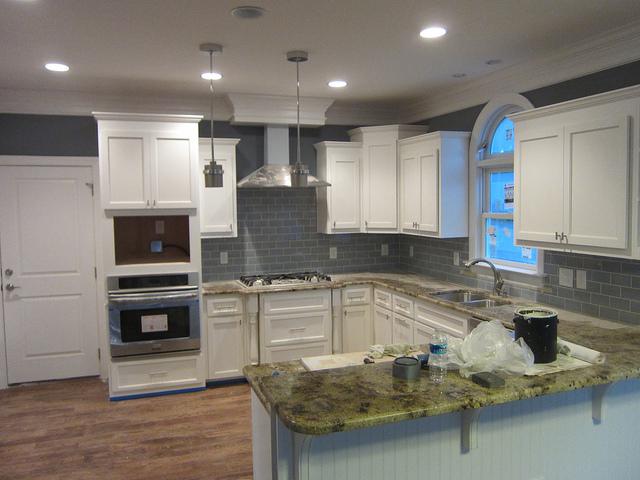Are there any ceiling lamps in this kitchen?
Write a very short answer. Yes. What is the countertop made out of?
Give a very brief answer. Granite. What room of the house is this?
Concise answer only. Kitchen. 